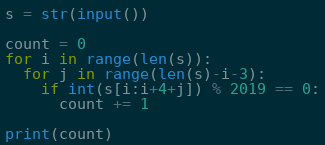Convert code to text. <code><loc_0><loc_0><loc_500><loc_500><_Python_>s = str(input())

count = 0
for i in range(len(s)):
  for j in range(len(s)-i-3):
    if int(s[i:i+4+j]) % 2019 == 0:
      count += 1
      
print(count)</code> 